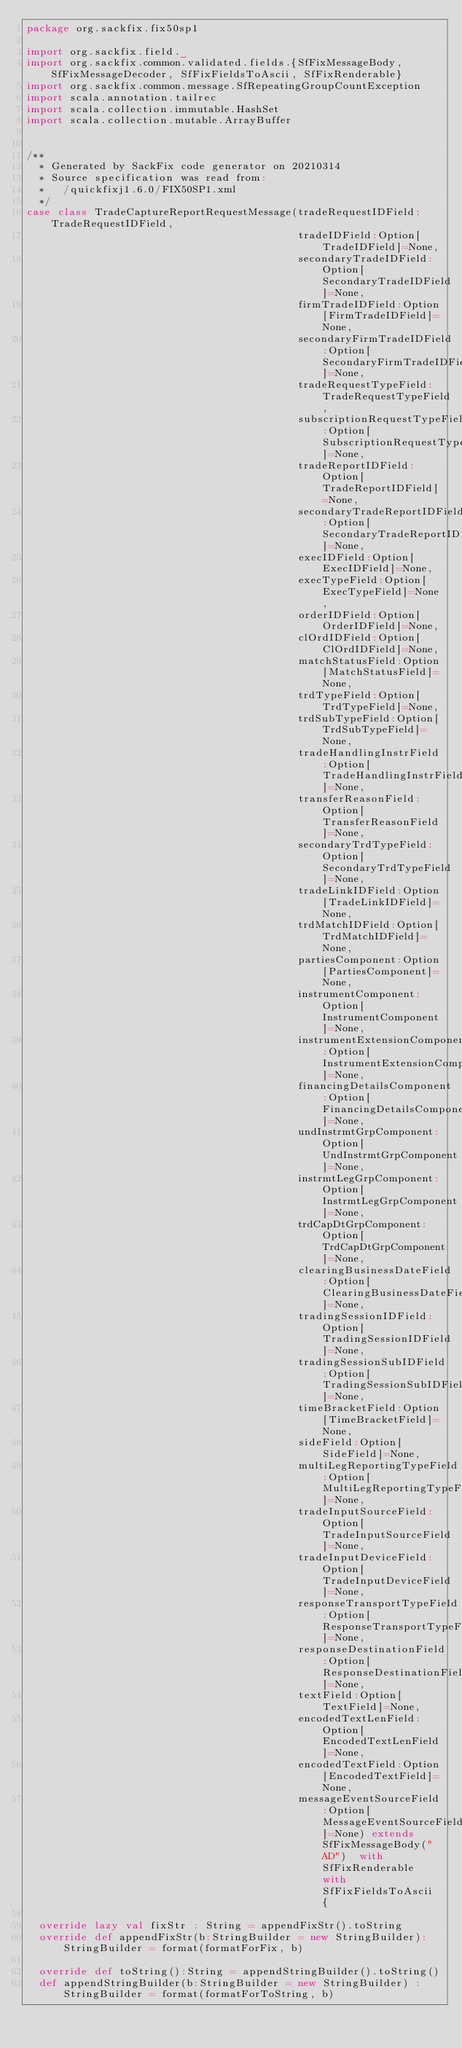Convert code to text. <code><loc_0><loc_0><loc_500><loc_500><_Scala_>package org.sackfix.fix50sp1

import org.sackfix.field._
import org.sackfix.common.validated.fields.{SfFixMessageBody, SfFixMessageDecoder, SfFixFieldsToAscii, SfFixRenderable}
import org.sackfix.common.message.SfRepeatingGroupCountException
import scala.annotation.tailrec
import scala.collection.immutable.HashSet
import scala.collection.mutable.ArrayBuffer


/**
  * Generated by SackFix code generator on 20210314
  * Source specification was read from:
  *   /quickfixj1.6.0/FIX50SP1.xml
  */
case class TradeCaptureReportRequestMessage(tradeRequestIDField:TradeRequestIDField,
                                            tradeIDField:Option[TradeIDField]=None,
                                            secondaryTradeIDField:Option[SecondaryTradeIDField]=None,
                                            firmTradeIDField:Option[FirmTradeIDField]=None,
                                            secondaryFirmTradeIDField:Option[SecondaryFirmTradeIDField]=None,
                                            tradeRequestTypeField:TradeRequestTypeField,
                                            subscriptionRequestTypeField:Option[SubscriptionRequestTypeField]=None,
                                            tradeReportIDField:Option[TradeReportIDField]=None,
                                            secondaryTradeReportIDField:Option[SecondaryTradeReportIDField]=None,
                                            execIDField:Option[ExecIDField]=None,
                                            execTypeField:Option[ExecTypeField]=None,
                                            orderIDField:Option[OrderIDField]=None,
                                            clOrdIDField:Option[ClOrdIDField]=None,
                                            matchStatusField:Option[MatchStatusField]=None,
                                            trdTypeField:Option[TrdTypeField]=None,
                                            trdSubTypeField:Option[TrdSubTypeField]=None,
                                            tradeHandlingInstrField:Option[TradeHandlingInstrField]=None,
                                            transferReasonField:Option[TransferReasonField]=None,
                                            secondaryTrdTypeField:Option[SecondaryTrdTypeField]=None,
                                            tradeLinkIDField:Option[TradeLinkIDField]=None,
                                            trdMatchIDField:Option[TrdMatchIDField]=None,
                                            partiesComponent:Option[PartiesComponent]=None,
                                            instrumentComponent:Option[InstrumentComponent]=None,
                                            instrumentExtensionComponent:Option[InstrumentExtensionComponent]=None,
                                            financingDetailsComponent:Option[FinancingDetailsComponent]=None,
                                            undInstrmtGrpComponent:Option[UndInstrmtGrpComponent]=None,
                                            instrmtLegGrpComponent:Option[InstrmtLegGrpComponent]=None,
                                            trdCapDtGrpComponent:Option[TrdCapDtGrpComponent]=None,
                                            clearingBusinessDateField:Option[ClearingBusinessDateField]=None,
                                            tradingSessionIDField:Option[TradingSessionIDField]=None,
                                            tradingSessionSubIDField:Option[TradingSessionSubIDField]=None,
                                            timeBracketField:Option[TimeBracketField]=None,
                                            sideField:Option[SideField]=None,
                                            multiLegReportingTypeField:Option[MultiLegReportingTypeField]=None,
                                            tradeInputSourceField:Option[TradeInputSourceField]=None,
                                            tradeInputDeviceField:Option[TradeInputDeviceField]=None,
                                            responseTransportTypeField:Option[ResponseTransportTypeField]=None,
                                            responseDestinationField:Option[ResponseDestinationField]=None,
                                            textField:Option[TextField]=None,
                                            encodedTextLenField:Option[EncodedTextLenField]=None,
                                            encodedTextField:Option[EncodedTextField]=None,
                                            messageEventSourceField:Option[MessageEventSourceField]=None) extends SfFixMessageBody("AD")  with SfFixRenderable with SfFixFieldsToAscii {

  override lazy val fixStr : String = appendFixStr().toString
  override def appendFixStr(b:StringBuilder = new StringBuilder): StringBuilder = format(formatForFix, b)

  override def toString():String = appendStringBuilder().toString()
  def appendStringBuilder(b:StringBuilder = new StringBuilder) : StringBuilder = format(formatForToString, b)
</code> 